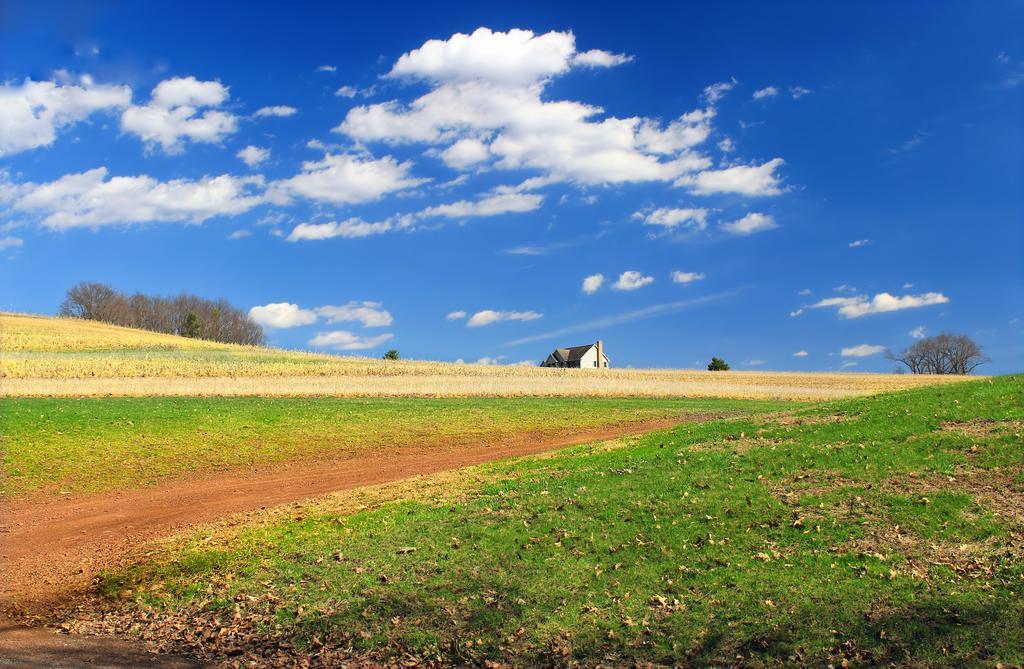Describe this image in one or two sentences. In this image we can see there is a grass on the surface of the area. At the center of the image there is a house. In the background there is a sky. 